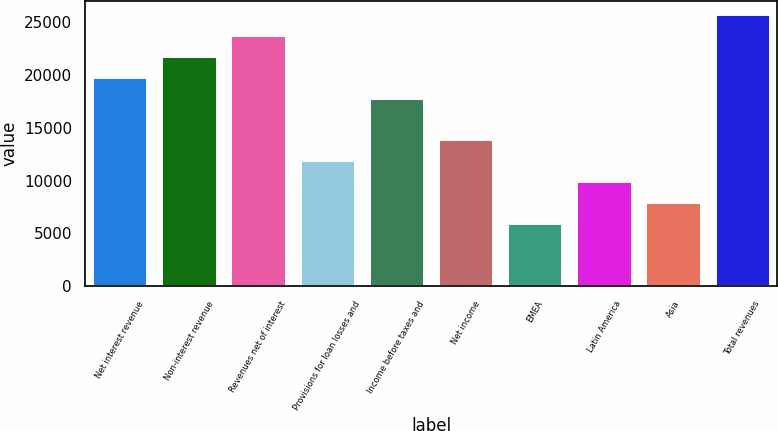Convert chart. <chart><loc_0><loc_0><loc_500><loc_500><bar_chart><fcel>Net interest revenue<fcel>Non-interest revenue<fcel>Revenues net of interest<fcel>Provisions for loan losses and<fcel>Income before taxes and<fcel>Net income<fcel>EMEA<fcel>Latin America<fcel>Asia<fcel>Total revenues<nl><fcel>19812<fcel>21785.8<fcel>23759.7<fcel>11916.6<fcel>17838.2<fcel>13890.5<fcel>5995.12<fcel>9942.8<fcel>7968.96<fcel>25733.5<nl></chart> 